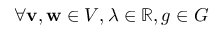Convert formula to latex. <formula><loc_0><loc_0><loc_500><loc_500>\forall v , w \in V , \lambda \in \mathbb { R } , g \in G</formula> 